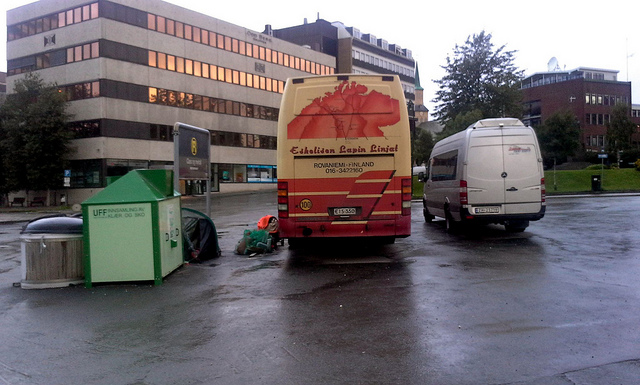<image>What does the writing on the back of the bus say? I don't know what the writing on the back of the bus says. It could possibly say "eshelian lepin linjet", "esbalion begin linjel", "cabolitan lupin linfel", "catholicism", "reservation" or "cabalison legion linel". What does the writing on the back of the bus say? I don't know what the writing on the back of the bus says. It seems to be in a language that I can't read. 